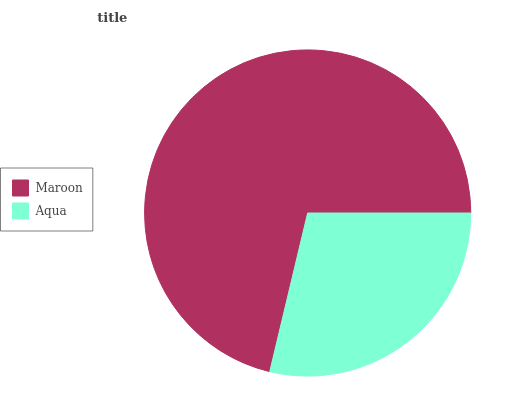Is Aqua the minimum?
Answer yes or no. Yes. Is Maroon the maximum?
Answer yes or no. Yes. Is Aqua the maximum?
Answer yes or no. No. Is Maroon greater than Aqua?
Answer yes or no. Yes. Is Aqua less than Maroon?
Answer yes or no. Yes. Is Aqua greater than Maroon?
Answer yes or no. No. Is Maroon less than Aqua?
Answer yes or no. No. Is Maroon the high median?
Answer yes or no. Yes. Is Aqua the low median?
Answer yes or no. Yes. Is Aqua the high median?
Answer yes or no. No. Is Maroon the low median?
Answer yes or no. No. 